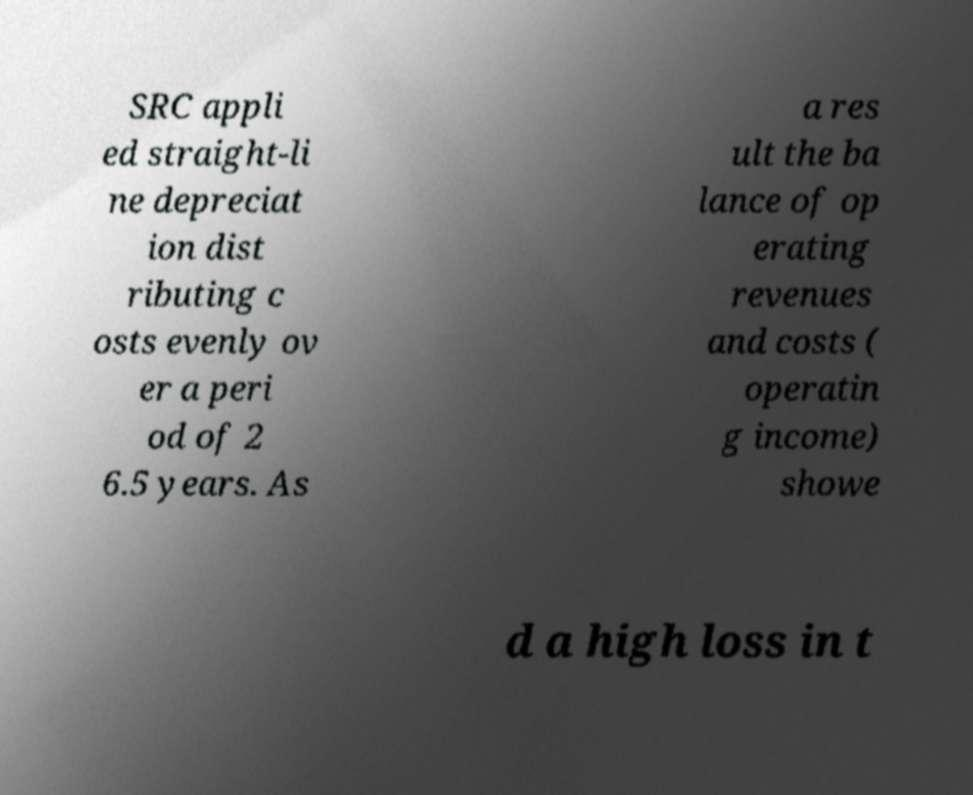Please identify and transcribe the text found in this image. SRC appli ed straight-li ne depreciat ion dist ributing c osts evenly ov er a peri od of 2 6.5 years. As a res ult the ba lance of op erating revenues and costs ( operatin g income) showe d a high loss in t 